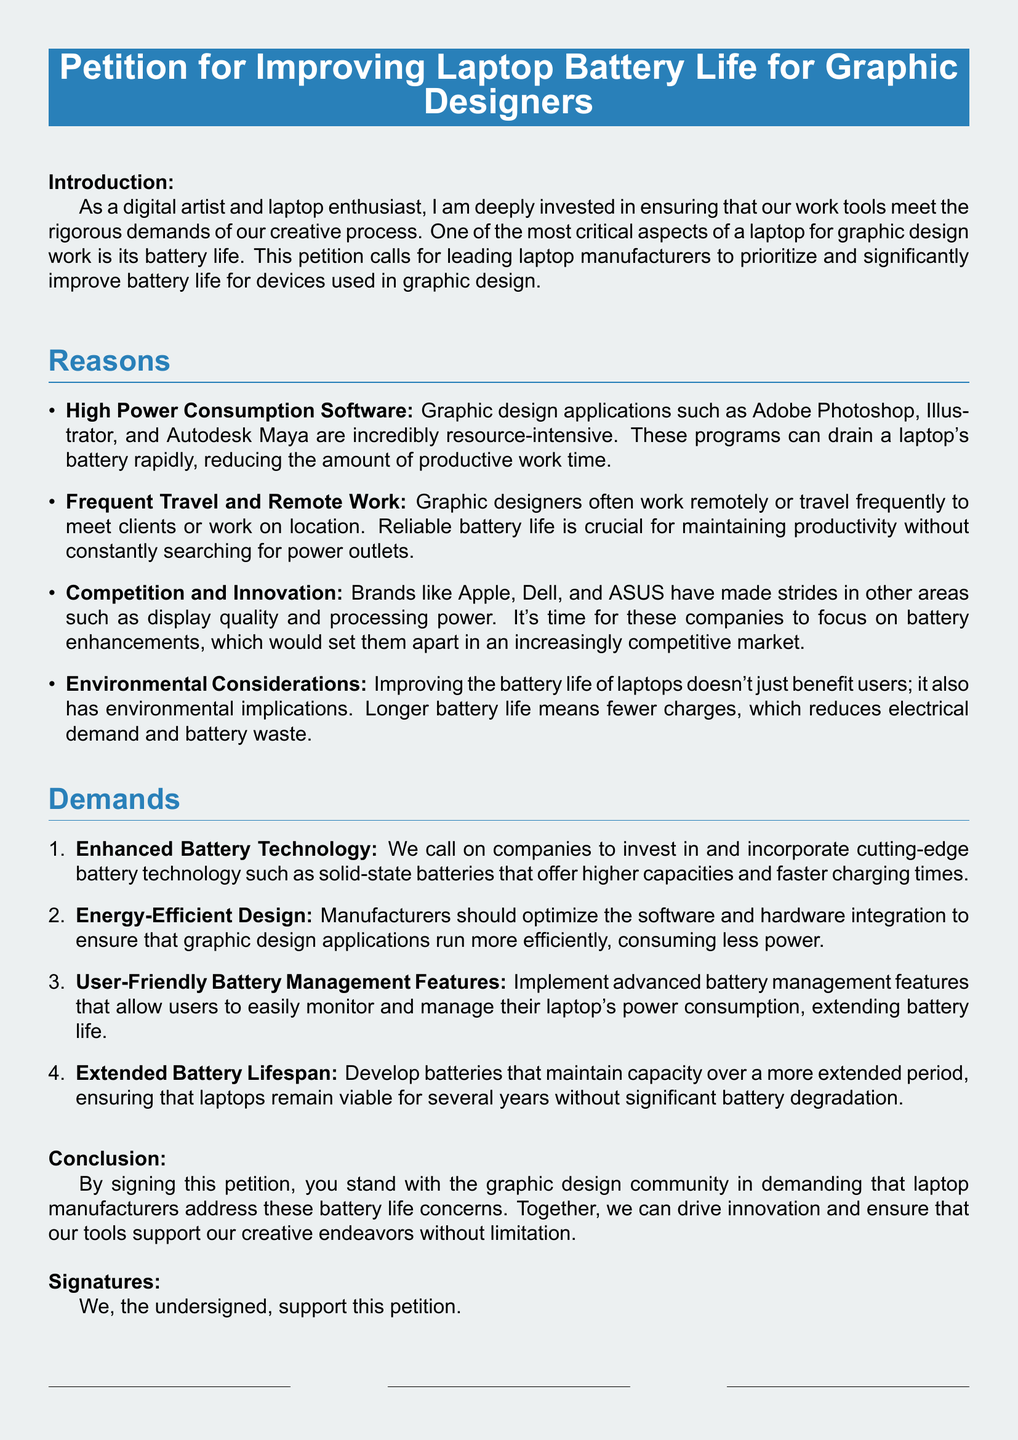What is the main focus of the petition? The petition focuses on improving battery life for laptops used in graphic design.
Answer: Improving laptop battery life for graphic designers How many reasons are listed in the petition? The petition lists four reasons for improving battery life.
Answer: Four Name one software mentioned that impacts battery life. The petition mentions Adobe Photoshop as a resource-intensive application.
Answer: Adobe Photoshop What is one demand of the petition? One demand is to enhance battery technology with cutting-edge solutions.
Answer: Enhanced Battery Technology According to the petition, why is reliable battery life crucial for graphic designers? Reliable battery life is crucial for maintaining productivity without constantly searching for power outlets.
Answer: Productivity without constantly searching for power outlets What environmental benefit is mentioned regarding improved battery life? Longer battery life reduces electrical demand and battery waste.
Answer: Reduces electrical demand and battery waste What should manufacturers optimize to improve battery life? Manufacturers should optimize software and hardware integration for efficiency.
Answer: Software and hardware integration Who does the petition call on to make these changes? The petition calls on leading laptop manufacturers to make improvements.
Answer: Leading laptop manufacturers 